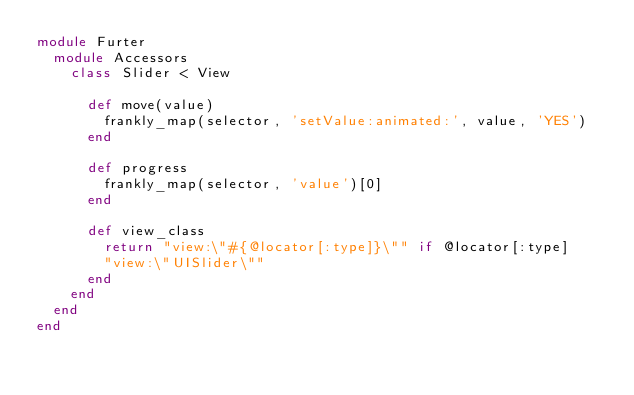Convert code to text. <code><loc_0><loc_0><loc_500><loc_500><_Ruby_>module Furter
  module Accessors
    class Slider < View

      def move(value)
        frankly_map(selector, 'setValue:animated:', value, 'YES')
      end

      def progress
        frankly_map(selector, 'value')[0]
      end

      def view_class
        return "view:\"#{@locator[:type]}\"" if @locator[:type]
        "view:\"UISlider\""
      end
    end
  end
end

</code> 